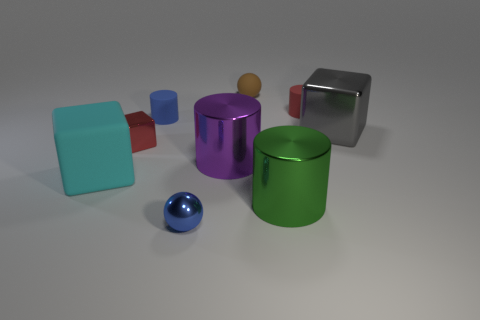Is there any other thing that is the same color as the small metal ball?
Offer a very short reply. Yes. The gray metallic thing that is the same shape as the large cyan rubber object is what size?
Offer a very short reply. Large. What is the material of the small cylinder that is the same color as the metallic ball?
Give a very brief answer. Rubber. Is there a yellow object of the same shape as the large green object?
Provide a succinct answer. No. There is a shiny sphere; does it have the same color as the cylinder that is to the left of the purple shiny object?
Keep it short and to the point. Yes. There is a thing that is the same color as the tiny cube; what size is it?
Offer a terse response. Small. Is there a metal sphere that has the same size as the brown matte thing?
Provide a short and direct response. Yes. Does the red cylinder have the same material as the large cylinder that is behind the big cyan matte object?
Provide a short and direct response. No. Is the number of green metal cylinders greater than the number of small blue things?
Make the answer very short. No. What number of cubes are either large gray matte things or purple things?
Offer a terse response. 0. 